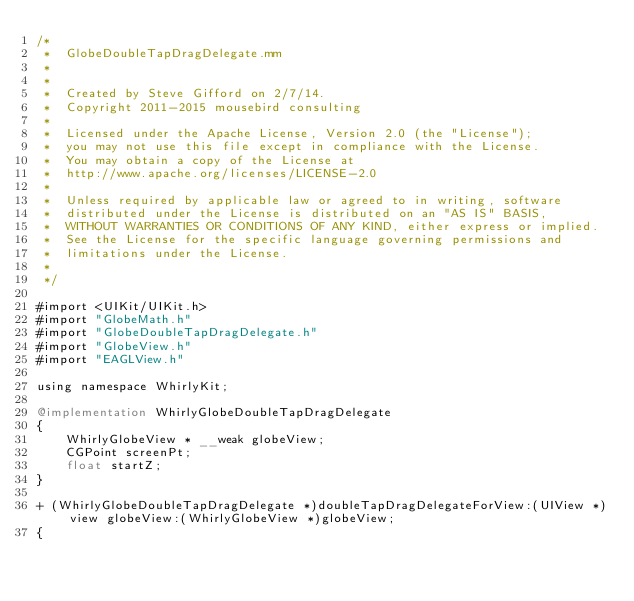Convert code to text. <code><loc_0><loc_0><loc_500><loc_500><_ObjectiveC_>/*
 *  GlobeDoubleTapDragDelegate.mm
 *
 *
 *  Created by Steve Gifford on 2/7/14.
 *  Copyright 2011-2015 mousebird consulting
 *
 *  Licensed under the Apache License, Version 2.0 (the "License");
 *  you may not use this file except in compliance with the License.
 *  You may obtain a copy of the License at
 *  http://www.apache.org/licenses/LICENSE-2.0
 *
 *  Unless required by applicable law or agreed to in writing, software
 *  distributed under the License is distributed on an "AS IS" BASIS,
 *  WITHOUT WARRANTIES OR CONDITIONS OF ANY KIND, either express or implied.
 *  See the License for the specific language governing permissions and
 *  limitations under the License.
 *
 */

#import <UIKit/UIKit.h>
#import "GlobeMath.h"
#import "GlobeDoubleTapDragDelegate.h"
#import "GlobeView.h"
#import "EAGLView.h"

using namespace WhirlyKit;

@implementation WhirlyGlobeDoubleTapDragDelegate
{
    WhirlyGlobeView * __weak globeView;
    CGPoint screenPt;
    float startZ;
}

+ (WhirlyGlobeDoubleTapDragDelegate *)doubleTapDragDelegateForView:(UIView *)view globeView:(WhirlyGlobeView *)globeView;
{</code> 